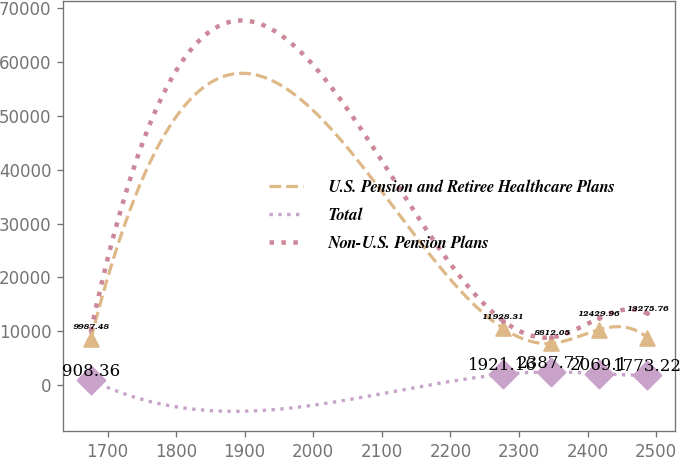Convert chart. <chart><loc_0><loc_0><loc_500><loc_500><line_chart><ecel><fcel>U.S. Pension and Retiree Healthcare Plans<fcel>Total<fcel>Non-U.S. Pension Plans<nl><fcel>1675.59<fcel>8429.58<fcel>908.36<fcel>9987.48<nl><fcel>2276.45<fcel>10517.4<fcel>1921.16<fcel>11928.3<nl><fcel>2346.7<fcel>7697.86<fcel>2387.77<fcel>8812.05<nl><fcel>2416.95<fcel>10258.5<fcel>2069.1<fcel>12430<nl><fcel>2487.2<fcel>8767.43<fcel>1773.22<fcel>13275.8<nl></chart> 